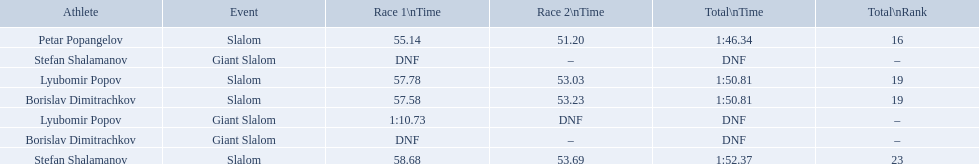Can you give me this table as a dict? {'header': ['Athlete', 'Event', 'Race 1\\nTime', 'Race 2\\nTime', 'Total\\nTime', 'Total\\nRank'], 'rows': [['Petar Popangelov', 'Slalom', '55.14', '51.20', '1:46.34', '16'], ['Stefan Shalamanov', 'Giant Slalom', 'DNF', '–', 'DNF', '–'], ['Lyubomir Popov', 'Slalom', '57.78', '53.03', '1:50.81', '19'], ['Borislav Dimitrachkov', 'Slalom', '57.58', '53.23', '1:50.81', '19'], ['Lyubomir Popov', 'Giant Slalom', '1:10.73', 'DNF', 'DNF', '–'], ['Borislav Dimitrachkov', 'Giant Slalom', 'DNF', '–', 'DNF', '–'], ['Stefan Shalamanov', 'Slalom', '58.68', '53.69', '1:52.37', '23']]} Which event is the giant slalom? Giant Slalom, Giant Slalom, Giant Slalom. Which one is lyubomir popov? Lyubomir Popov. What is race 1 tim? 1:10.73. 